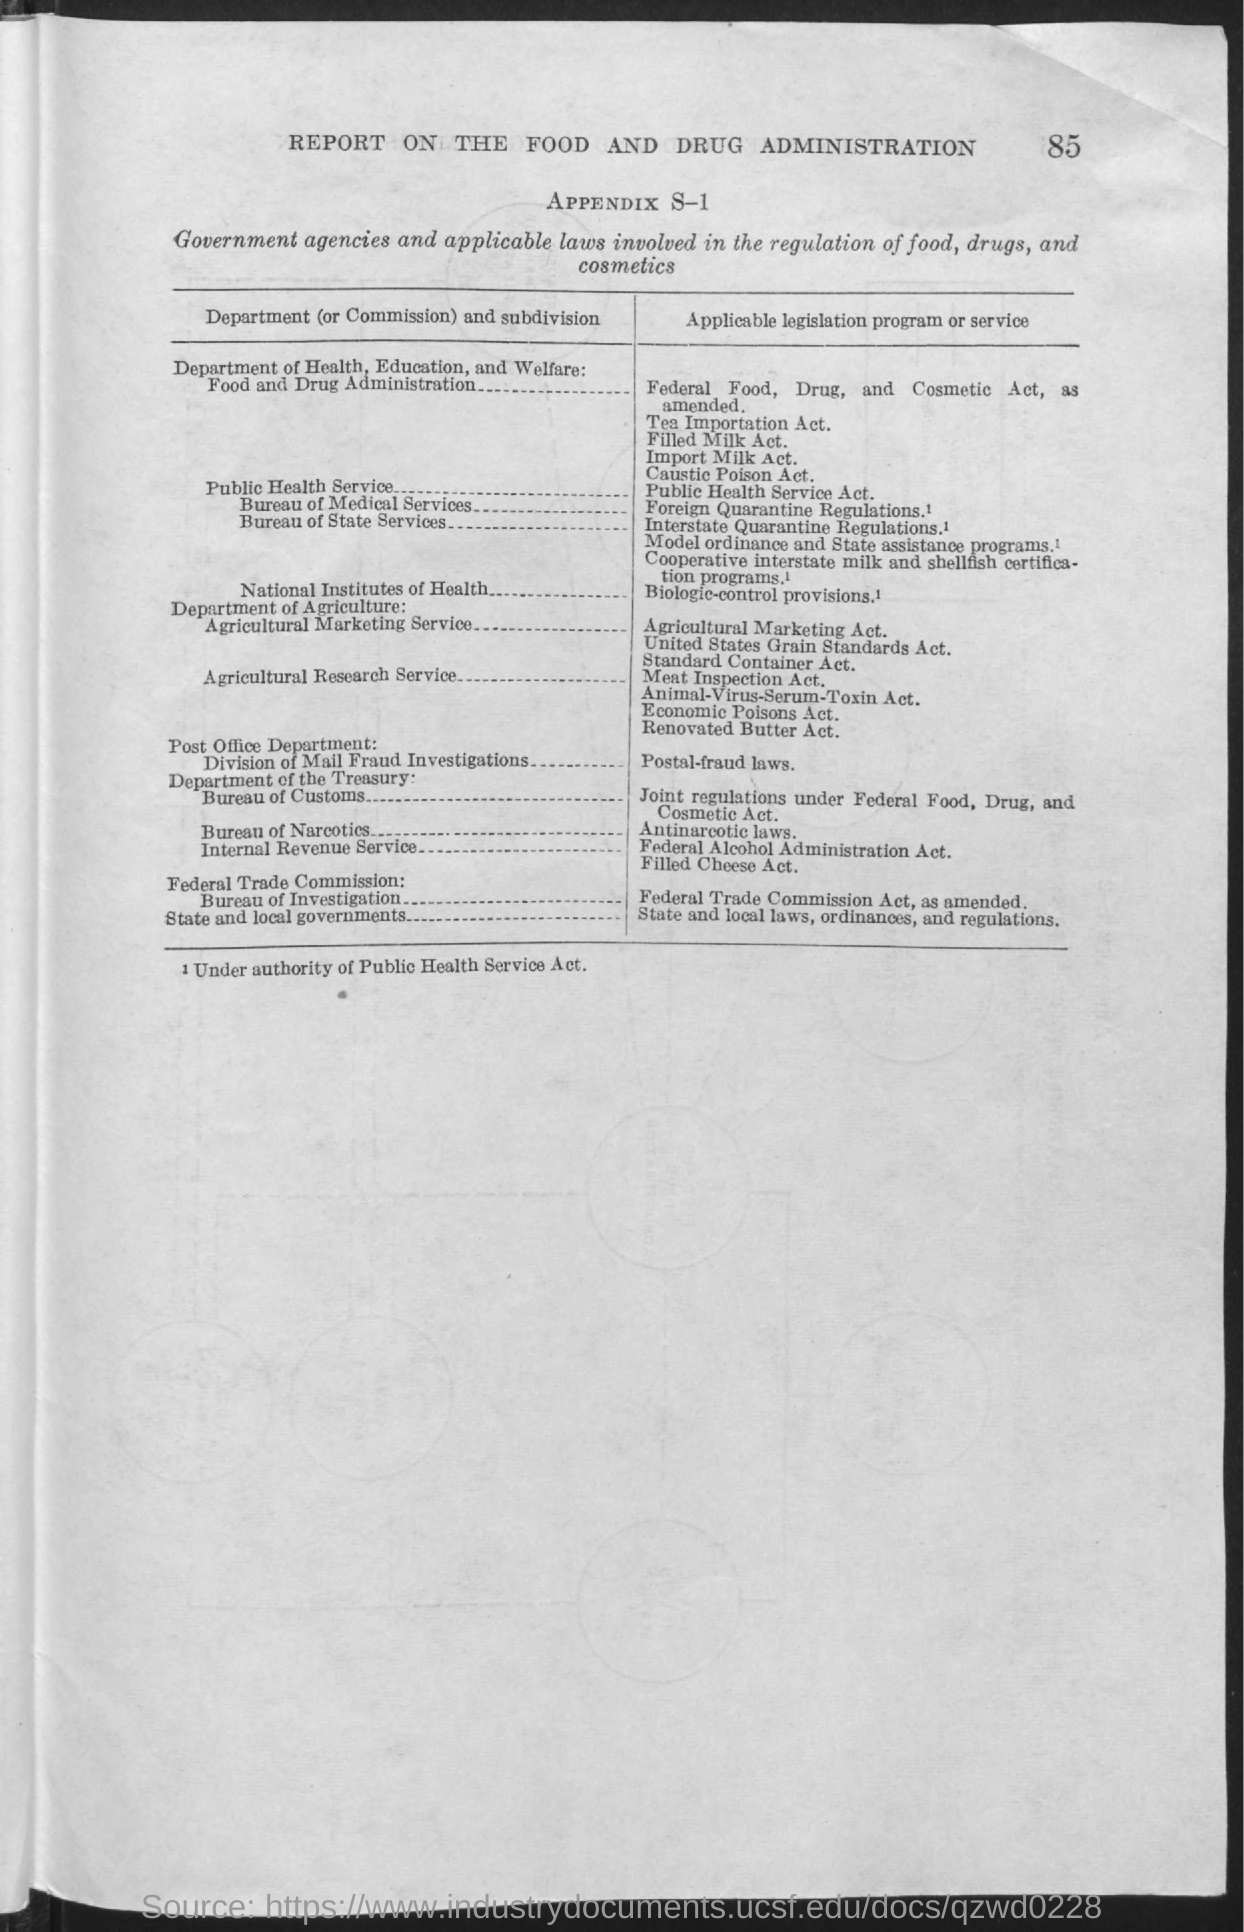Specify some key components in this picture. The title of the report is a report on the Food and Drug Administration. 